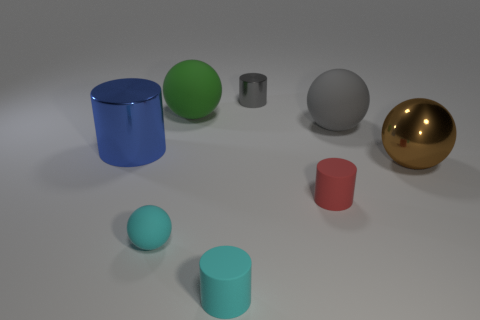Add 1 gray matte things. How many objects exist? 9 Add 5 small red rubber cylinders. How many small red rubber cylinders are left? 6 Add 1 big rubber cylinders. How many big rubber cylinders exist? 1 Subtract 1 gray spheres. How many objects are left? 7 Subtract all large brown shiny cylinders. Subtract all gray matte balls. How many objects are left? 7 